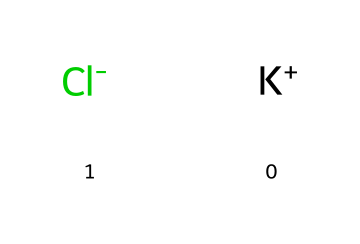What atoms are present in this chemical? The chemical structure shows two distinct ions: potassium (K) and chloride (Cl). Therefore, the atoms are identified directly from the SMILES notation.
Answer: potassium and chloride How many atoms are in potassium chloride? The chemical is composed of one potassium ion and one chloride ion, resulting in a total of two atoms in the structure.
Answer: two What type of bond is present in potassium chloride? Potassium chloride consists of an ionic bond, where the potassium ion donates an electron to the chloride ion, leading to electrostatic attraction between the oppositely charged ions.
Answer: ionic bond What is the charge of the potassium ion in this electrolyte? The potassium ion, as indicated in the SMILES notation ([K+]), has a single positive charge, representing its loss of one electron.
Answer: positive Why is potassium chloride considered an essential electrolyte? Potassium chloride is vital for maintaining electrical balance in the body, particularly in heart function, by managing nerve impulses and muscle contractions, which are crucial processes for cardiovascular health.
Answer: essential for heart function How does potassium ion function in the body? The potassium ion helps regulate fluid balance, muscle contractions, and nerve signals, contributing to overall cellular function and is particularly important for the normal rhythm of the heart.
Answer: regulates fluid balance and nerve signals 